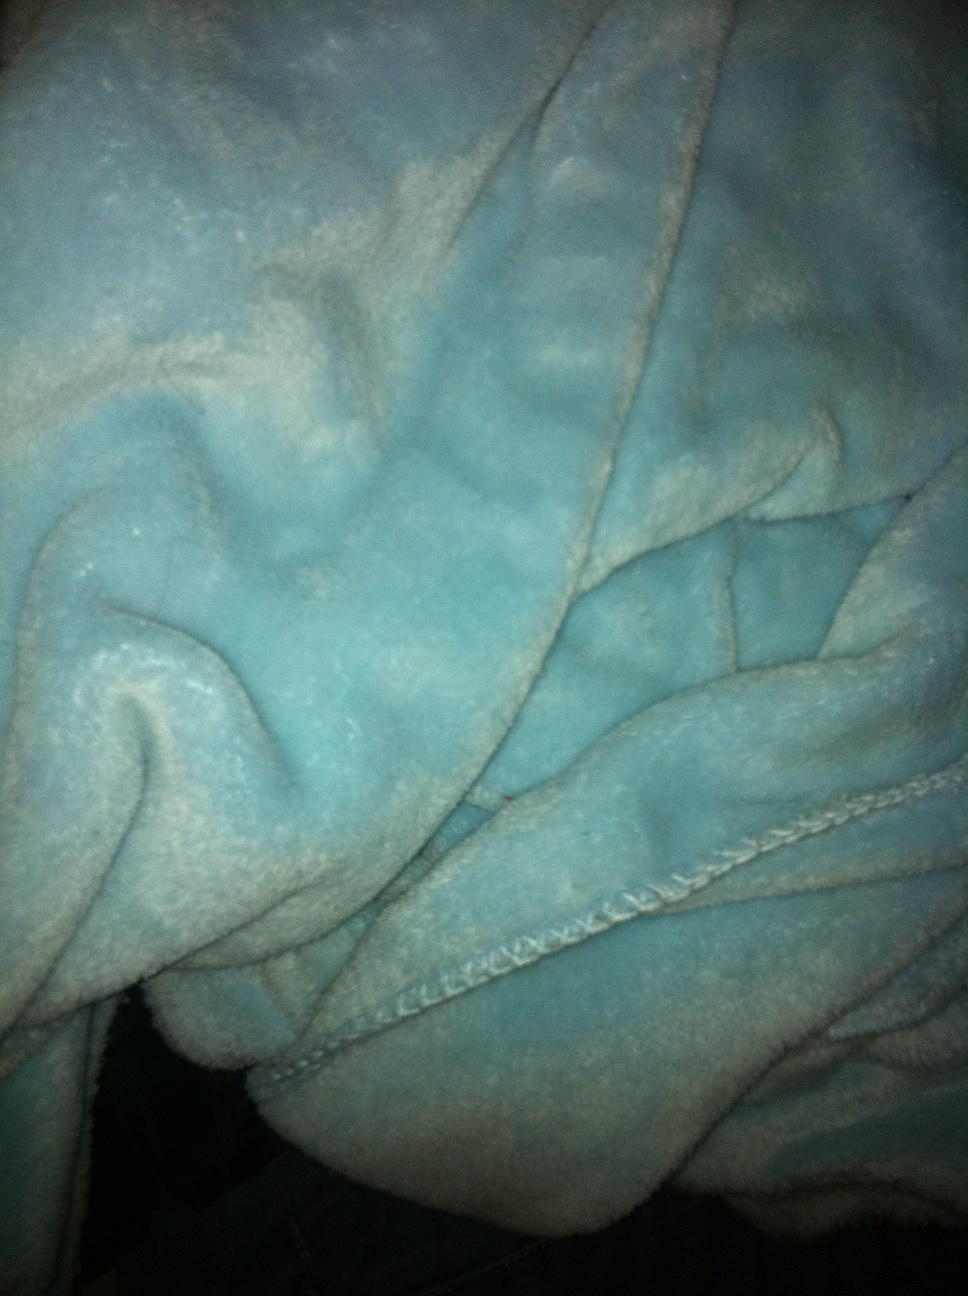Is the color of the robe more suitable for a particular season or aesthetic? The teal color of the robe has a versatile quality to it, making it suitable for any season. In summer, it reflects the colors of the ocean and in winter, it pairs well with the cooler palette. Aesthetically, it's a hue that can fit with both a modern, minimalist decor or a more traditional, comfy home setting due to its calming yet rich tone. 